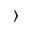Convert formula to latex. <formula><loc_0><loc_0><loc_500><loc_500>\rangle</formula> 